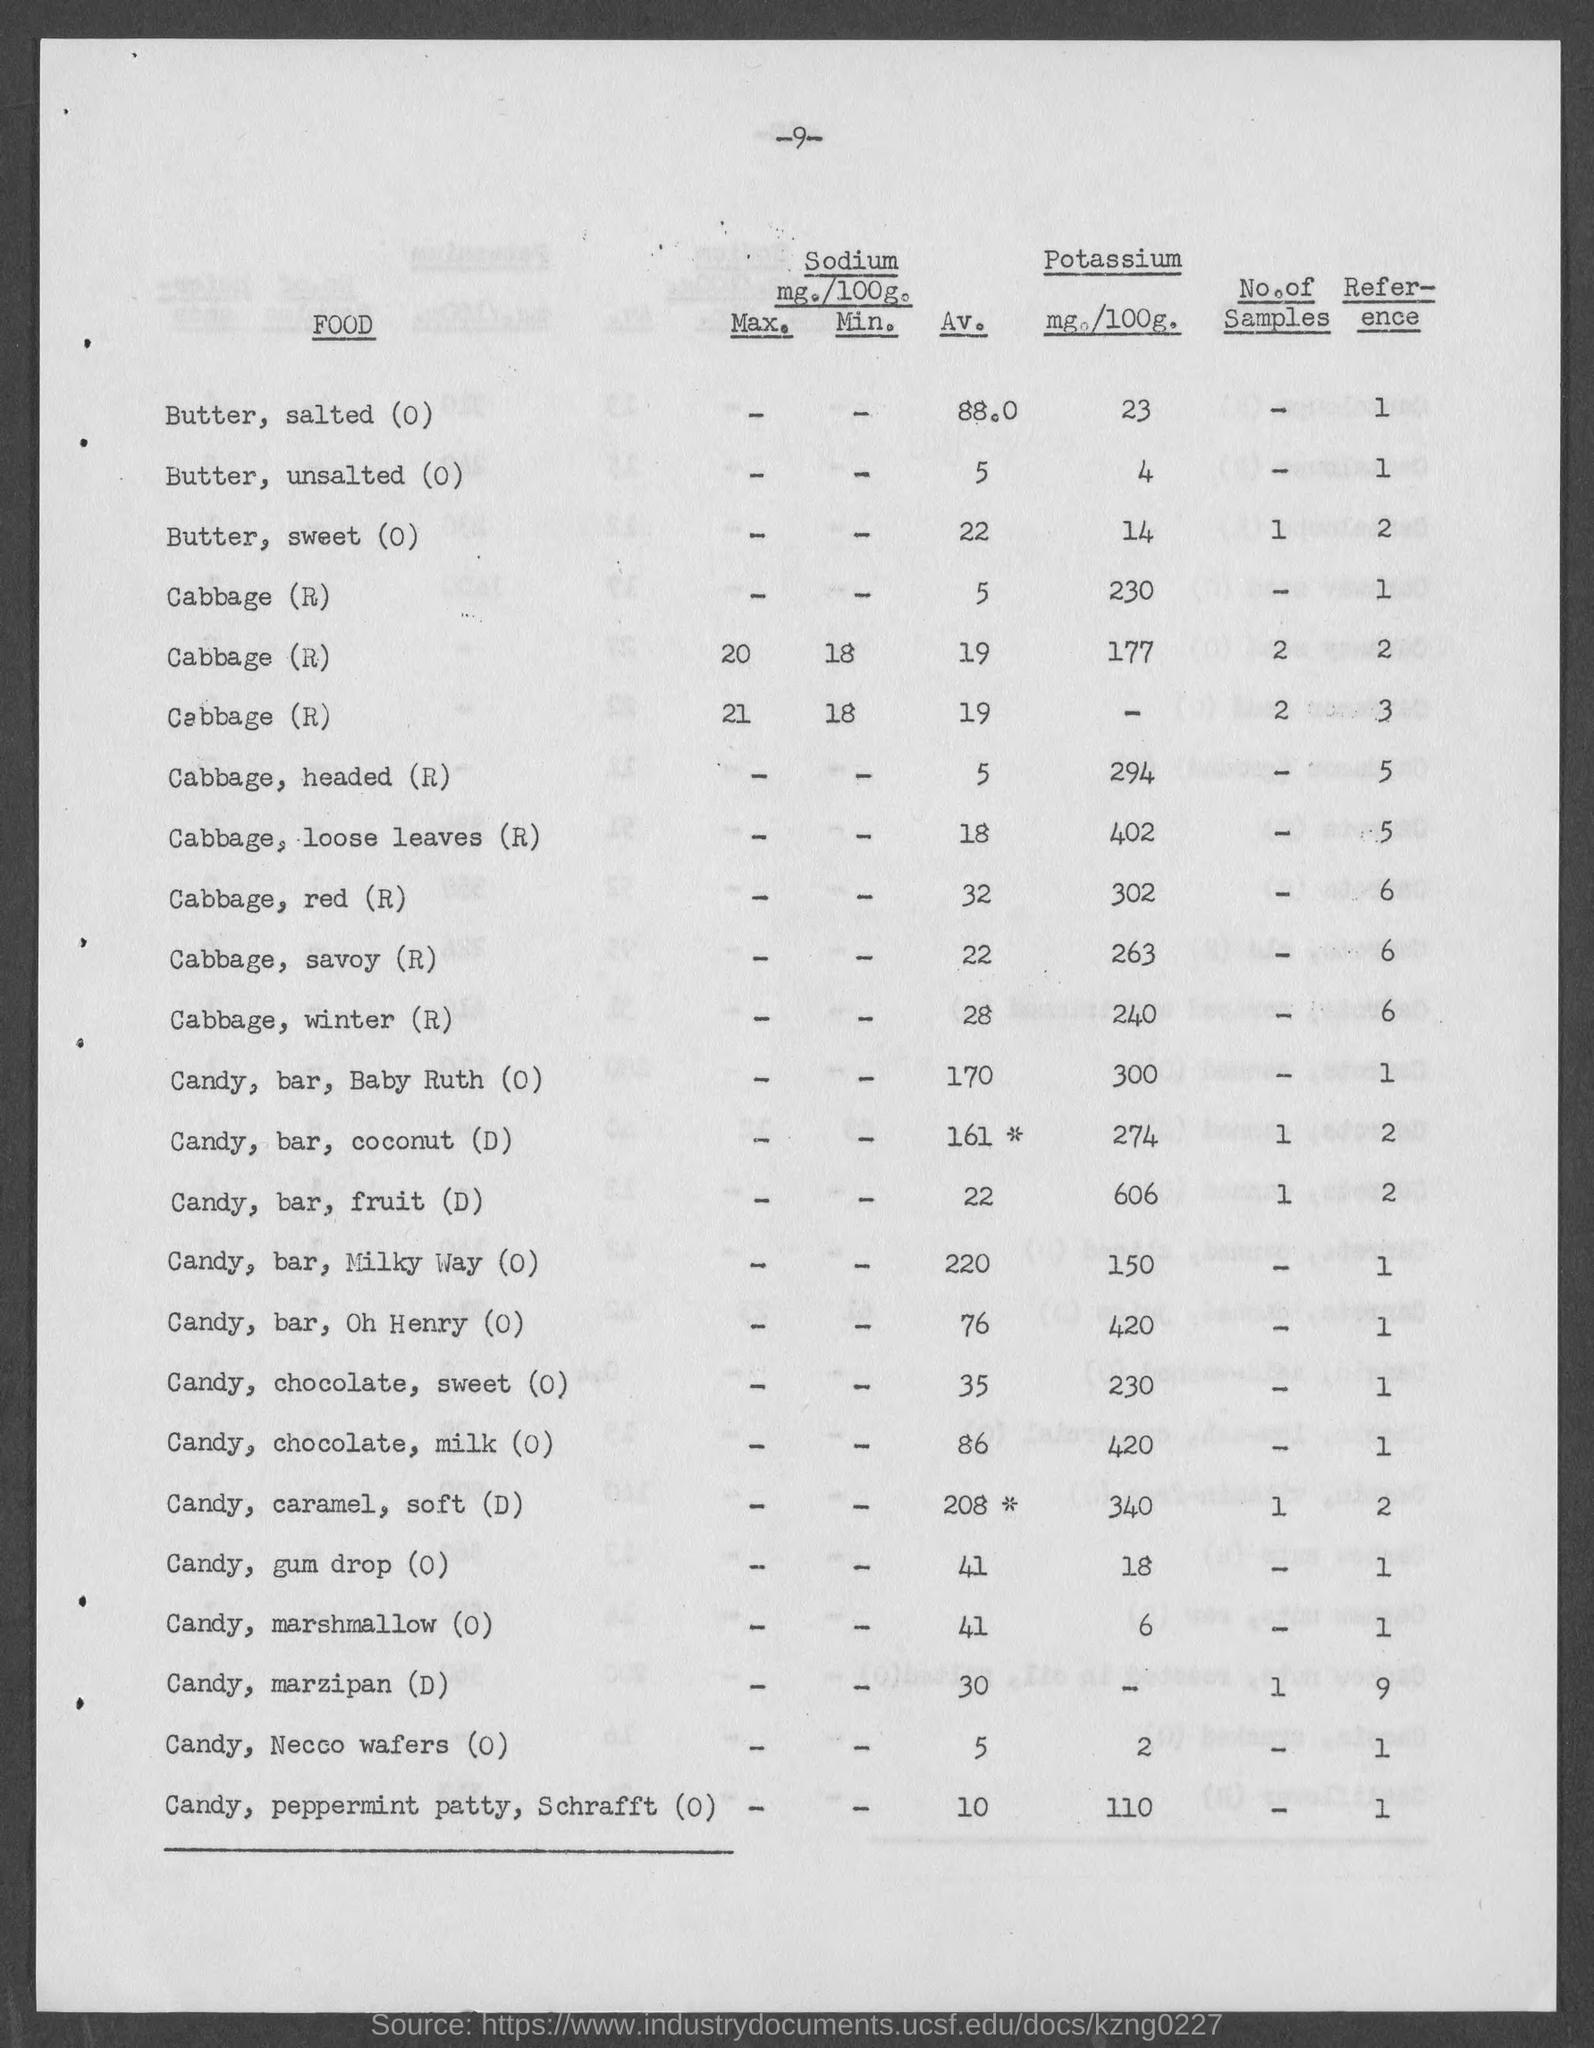What is the av. value of sodium in butter,salted(o) as mentioned in the given page ?
Give a very brief answer. 88.0. What is the av. value of sodium in butter,unsalted(o) as mentioned in the given page ?
Your response must be concise. 5. What is the amount of potassium present in butter, salted(o) as mentioned in the given page ?
Offer a terse response. 23. What is the amount of potassium present in butter, unsalted(o) as mentioned in the given page ?
Your answer should be compact. 4. What is the amount of potassium present in butter, sweet(o) as mentioned in the given page ?
Your response must be concise. 14. What is the av. value of sodium in butter,sweet (o) as mentioned in the given page ?
Provide a short and direct response. 22. What is the amount of potassium present in cabbage , red(r) as mentioned in the given page ?
Your response must be concise. 302. What is the amount of potassium present in cabbage , winter(r) as mentioned in the given page ?
Your response must be concise. 240. What is the amount of potassium present in candy, gum drop(o) as mentioned in the given page ?
Offer a very short reply. 18. What is the amount of potassium present in candy,bar,fruit(d) as mentioned in the given page ?
Your answer should be very brief. 606. 